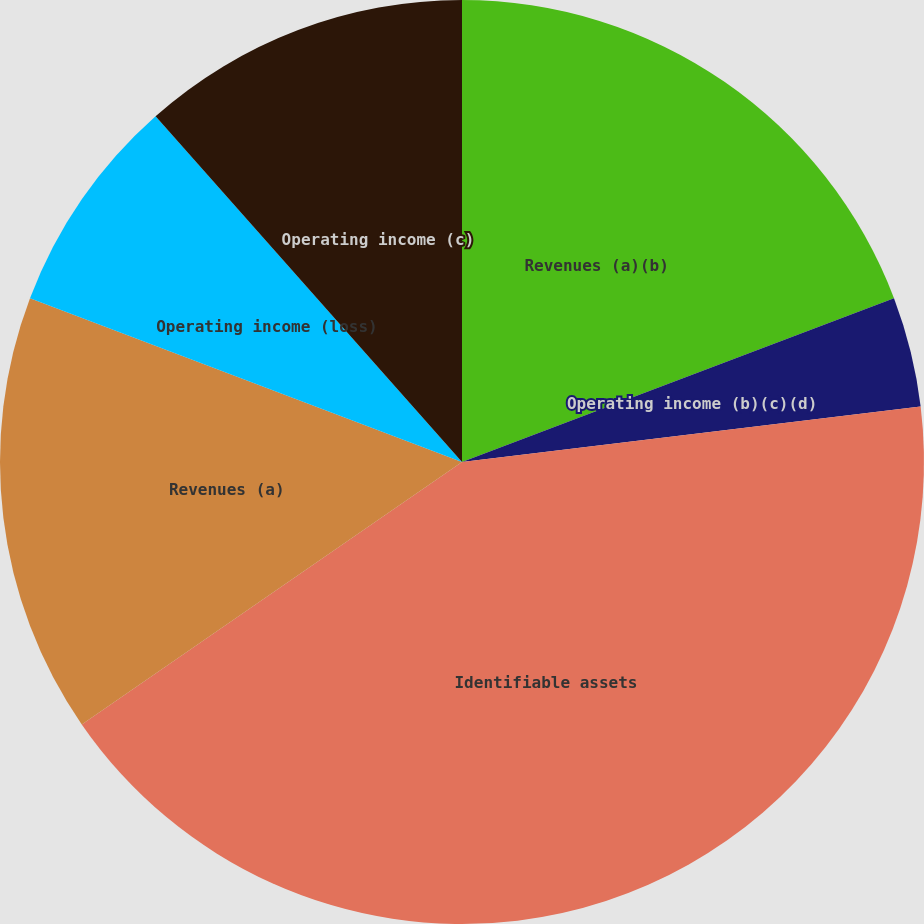Convert chart. <chart><loc_0><loc_0><loc_500><loc_500><pie_chart><fcel>Revenues (a)(b)<fcel>Operating income (b)(c)(d)<fcel>Identifiable assets<fcel>Revenues (a)<fcel>Operating income (loss)<fcel>Operating income (c)<nl><fcel>19.23%<fcel>3.85%<fcel>42.3%<fcel>15.38%<fcel>7.69%<fcel>11.54%<nl></chart> 